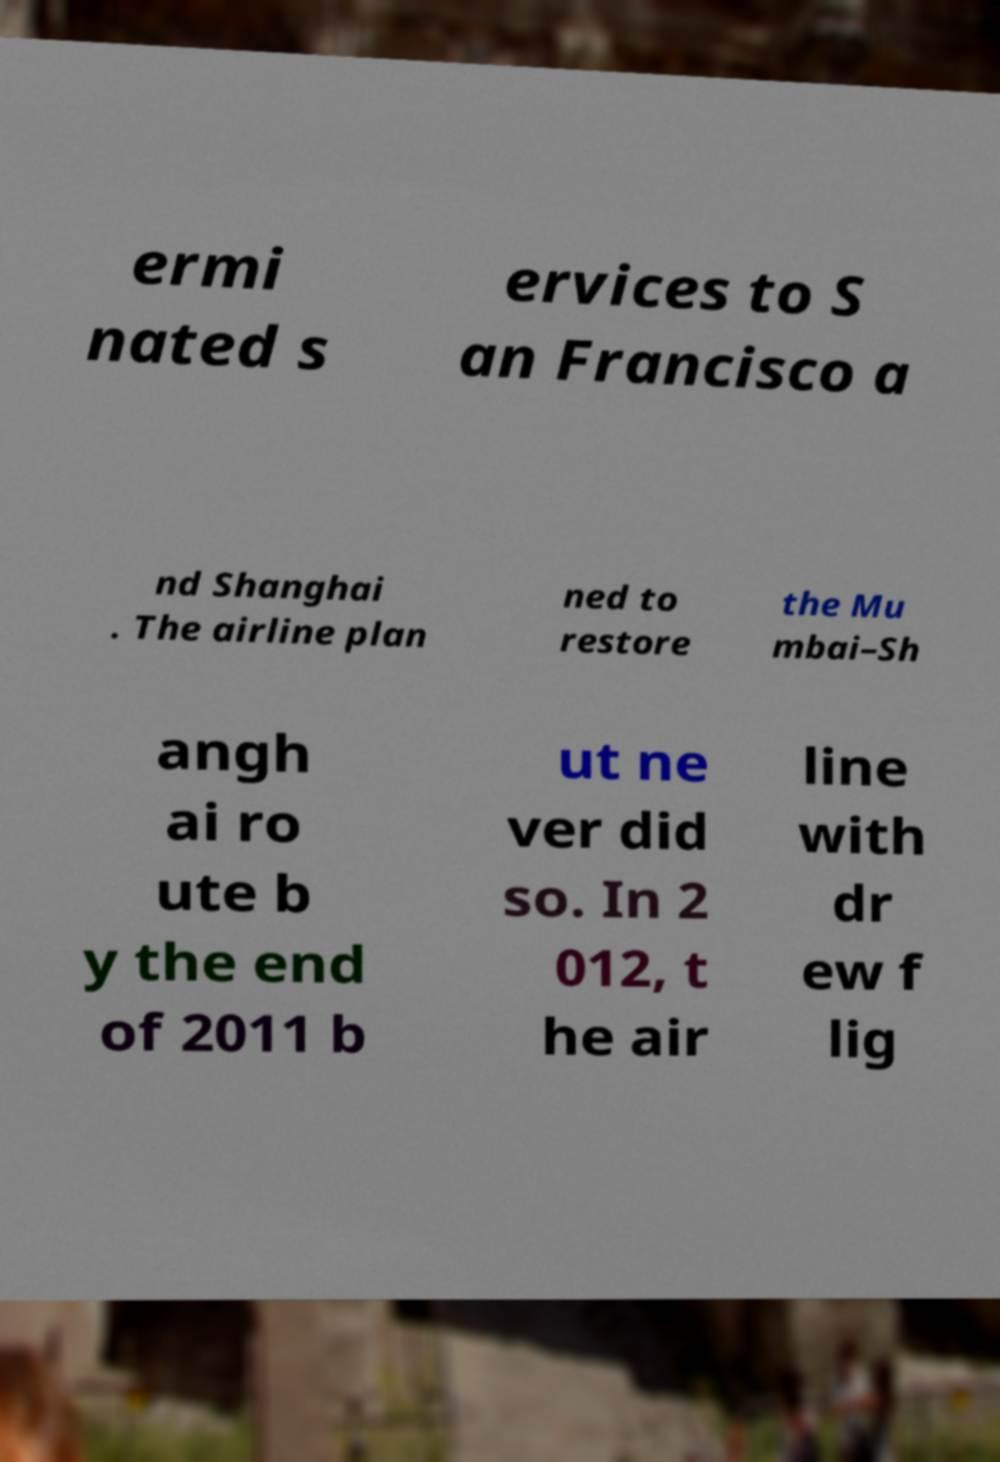For documentation purposes, I need the text within this image transcribed. Could you provide that? ermi nated s ervices to S an Francisco a nd Shanghai . The airline plan ned to restore the Mu mbai–Sh angh ai ro ute b y the end of 2011 b ut ne ver did so. In 2 012, t he air line with dr ew f lig 